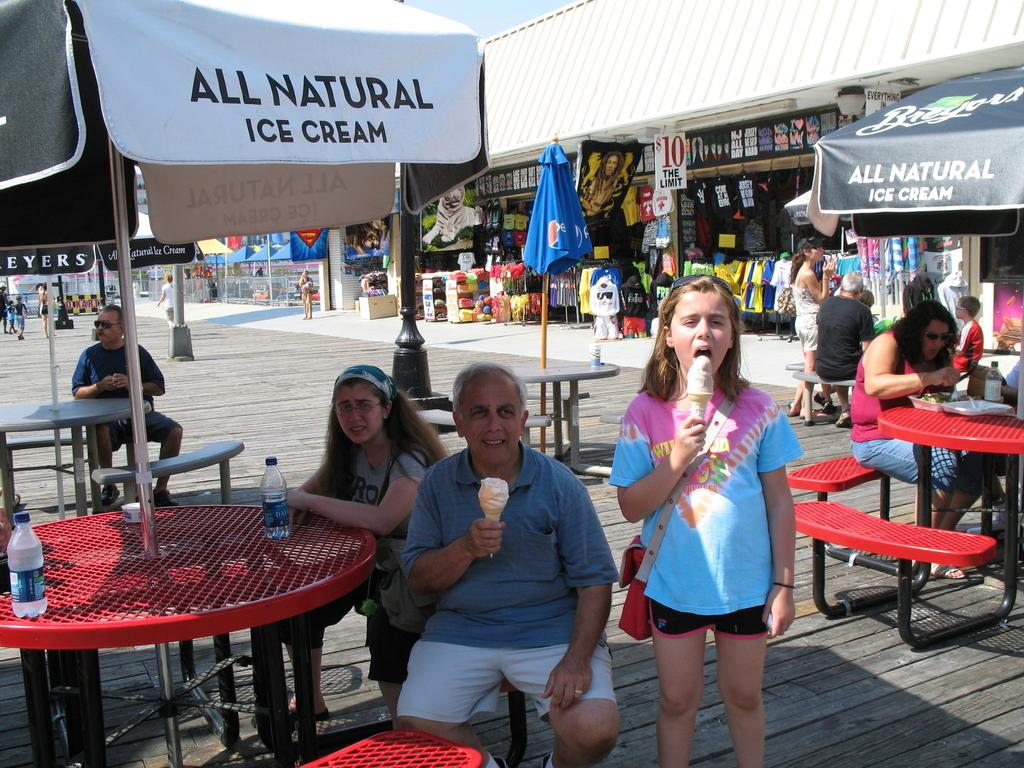What are the people in the image doing? There are people sitting on a bench in the image. What can be seen on the table in the image? There is a water bottle on a table in the image. What is the girl in the image wearing? The girl is wearing a bag in the image. What is the girl eating in the image? The girl is eating ice cream in the image. What type of buildings can be seen in the background of the image? There are stores visible in the background of the image. Can you see the fang of the animal in the image? There is no animal with a fang present in the image. What type of powder is being used by the people in the image? There is no powder being used by the people in the image. 